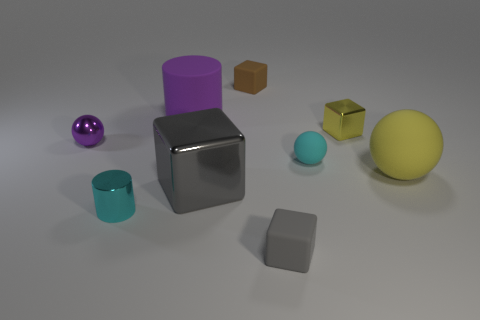What is the size of the yellow thing that is made of the same material as the small brown block?
Provide a succinct answer. Large. There is a tiny block that is the same material as the cyan cylinder; what color is it?
Offer a terse response. Yellow. Is there a cyan metal object that has the same size as the purple shiny ball?
Your answer should be compact. Yes. What material is the tiny brown thing that is the same shape as the gray rubber object?
Your answer should be very brief. Rubber. There is a purple metal thing that is the same size as the cyan matte object; what shape is it?
Your answer should be compact. Sphere. Is there another large matte thing that has the same shape as the brown rubber thing?
Offer a very short reply. No. What shape is the big rubber thing on the right side of the large rubber object that is to the left of the brown object?
Ensure brevity in your answer.  Sphere. There is a purple shiny thing; what shape is it?
Make the answer very short. Sphere. There is a gray block right of the small rubber block that is behind the block that is right of the cyan rubber object; what is its material?
Provide a succinct answer. Rubber. What number of other objects are the same material as the small gray thing?
Ensure brevity in your answer.  4. 